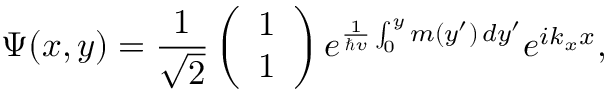Convert formula to latex. <formula><loc_0><loc_0><loc_500><loc_500>\Psi ( x , y ) = \frac { 1 } { \sqrt { 2 } } \left ( \begin{array} { l } { 1 } \\ { 1 } \end{array} \right ) e ^ { \frac { 1 } { \hbar { v } } \int _ { 0 } ^ { y } m ( y ^ { \prime } ) \, d y ^ { \prime } } e ^ { i k _ { x } x } ,</formula> 